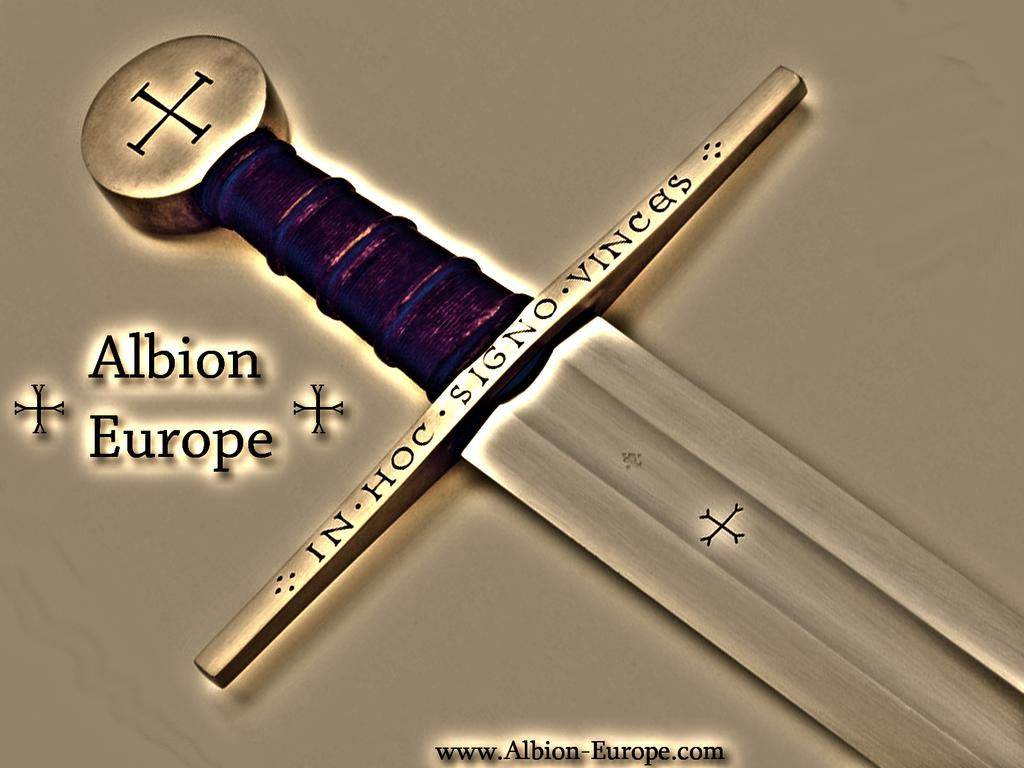What is the main object in the center of the image? There is a sword in the center of the image. Are there any words or letters on the sword? Yes, there is text on the sword. Is there any text visible outside of the sword in the image? Yes, there is text at the bottom of the image. What type of voice can be heard coming from the stage in the image? There is no stage present in the image, so it is not possible to determine if a voice can be heard. 